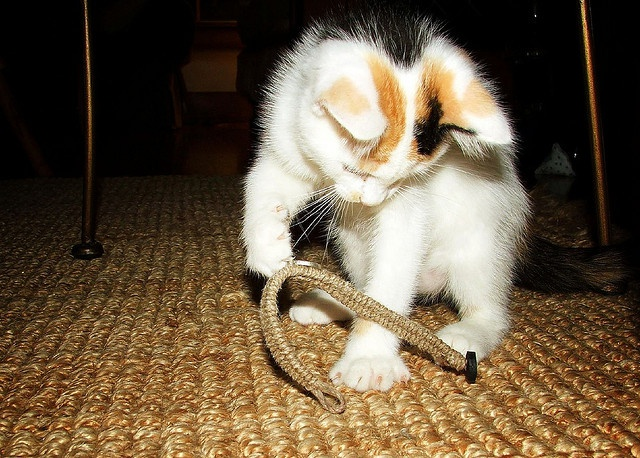Describe the objects in this image and their specific colors. I can see a cat in black, ivory, tan, and darkgray tones in this image. 